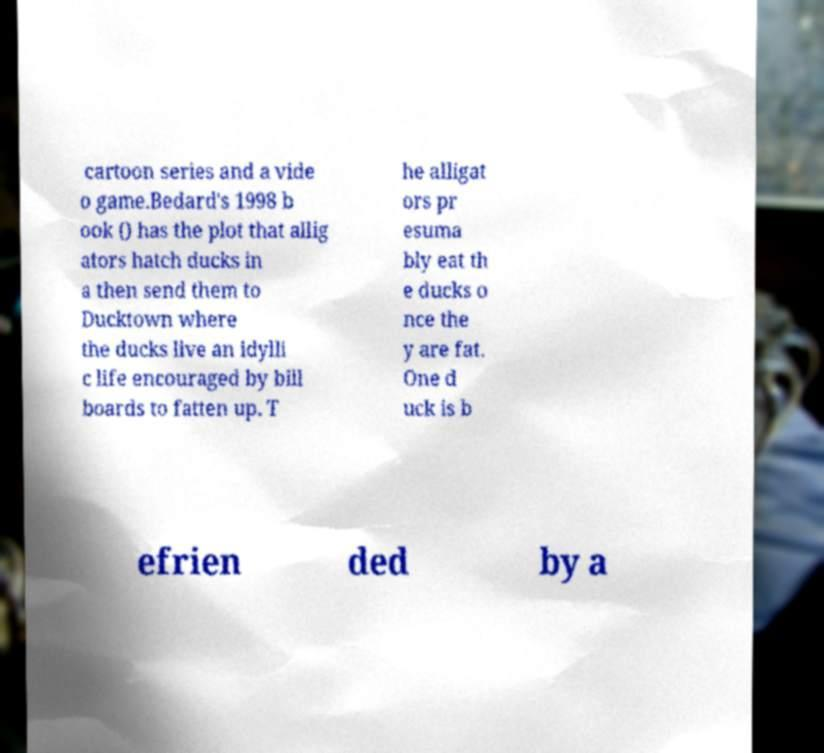What messages or text are displayed in this image? I need them in a readable, typed format. cartoon series and a vide o game.Bedard's 1998 b ook () has the plot that allig ators hatch ducks in a then send them to Ducktown where the ducks live an idylli c life encouraged by bill boards to fatten up. T he alligat ors pr esuma bly eat th e ducks o nce the y are fat. One d uck is b efrien ded by a 